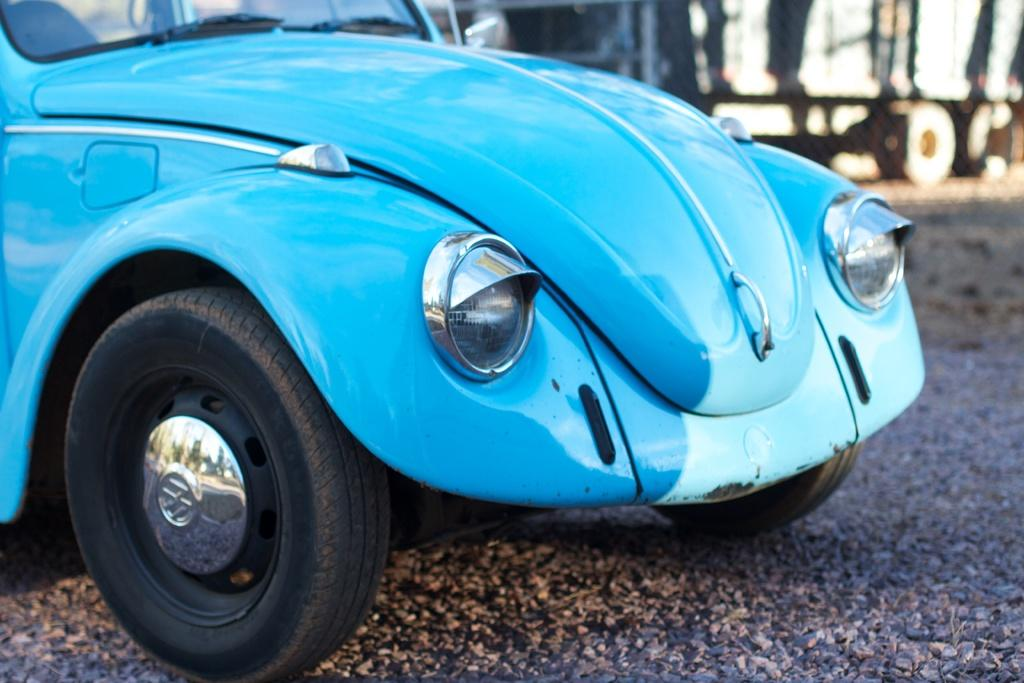What type of vehicle is in the image? There is a blue car in the image. What specific feature can be seen on the car? The car has headlights. Where are the headlights located in the image? The headlights are placed on the ground. What other vehicle can be seen in the background of the image? There is a truck in the background of the image. What type of art can be seen in the image? There is no art present in the image; it features a blue car with headlights on the ground and a truck in the background. How does the town appear in the image? The image does not depict a town; it shows a blue car, headlights on the ground, and a truck in the background. 